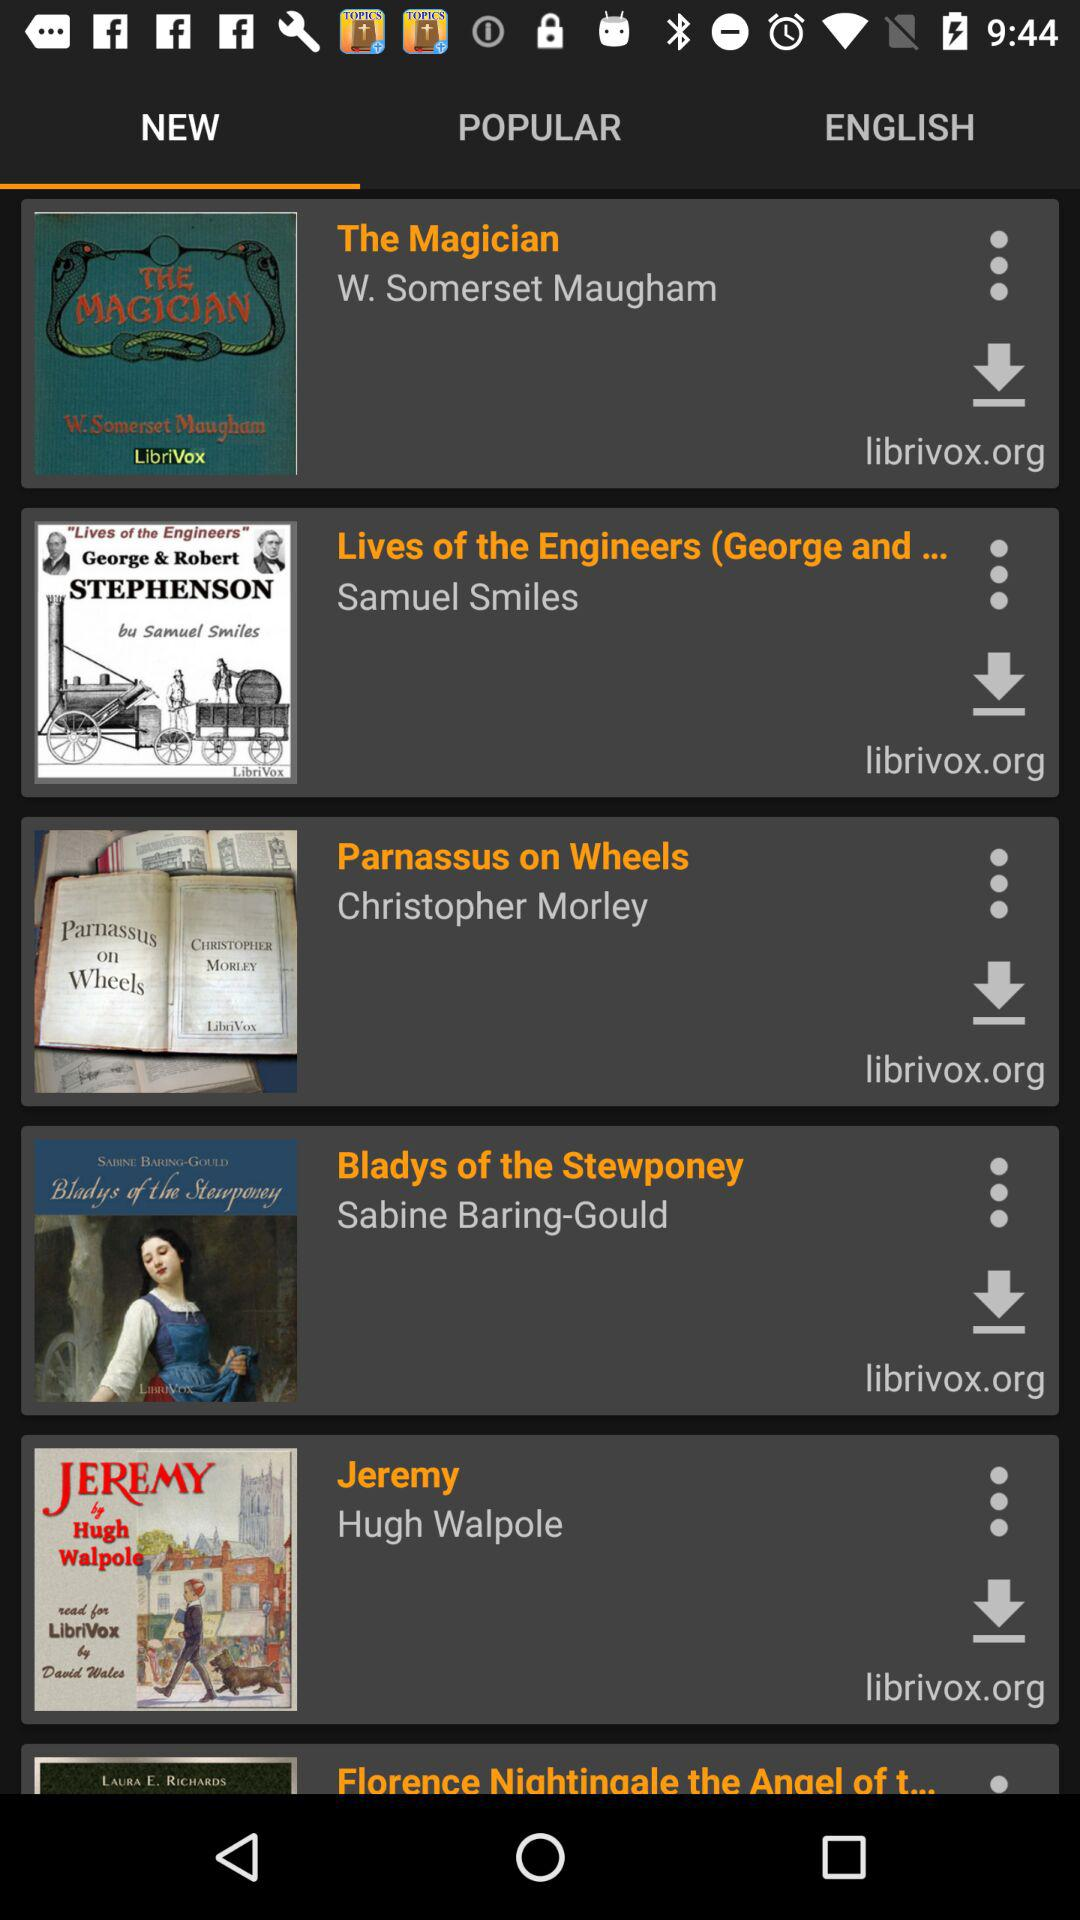Who is the author of "Bladys of the Stewponey"? The author is Sabine Baring-Gould. 